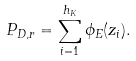<formula> <loc_0><loc_0><loc_500><loc_500>P _ { D , r } = \sum _ { i = 1 } ^ { h _ { K } } \phi _ { E } ( z _ { i } ) .</formula> 